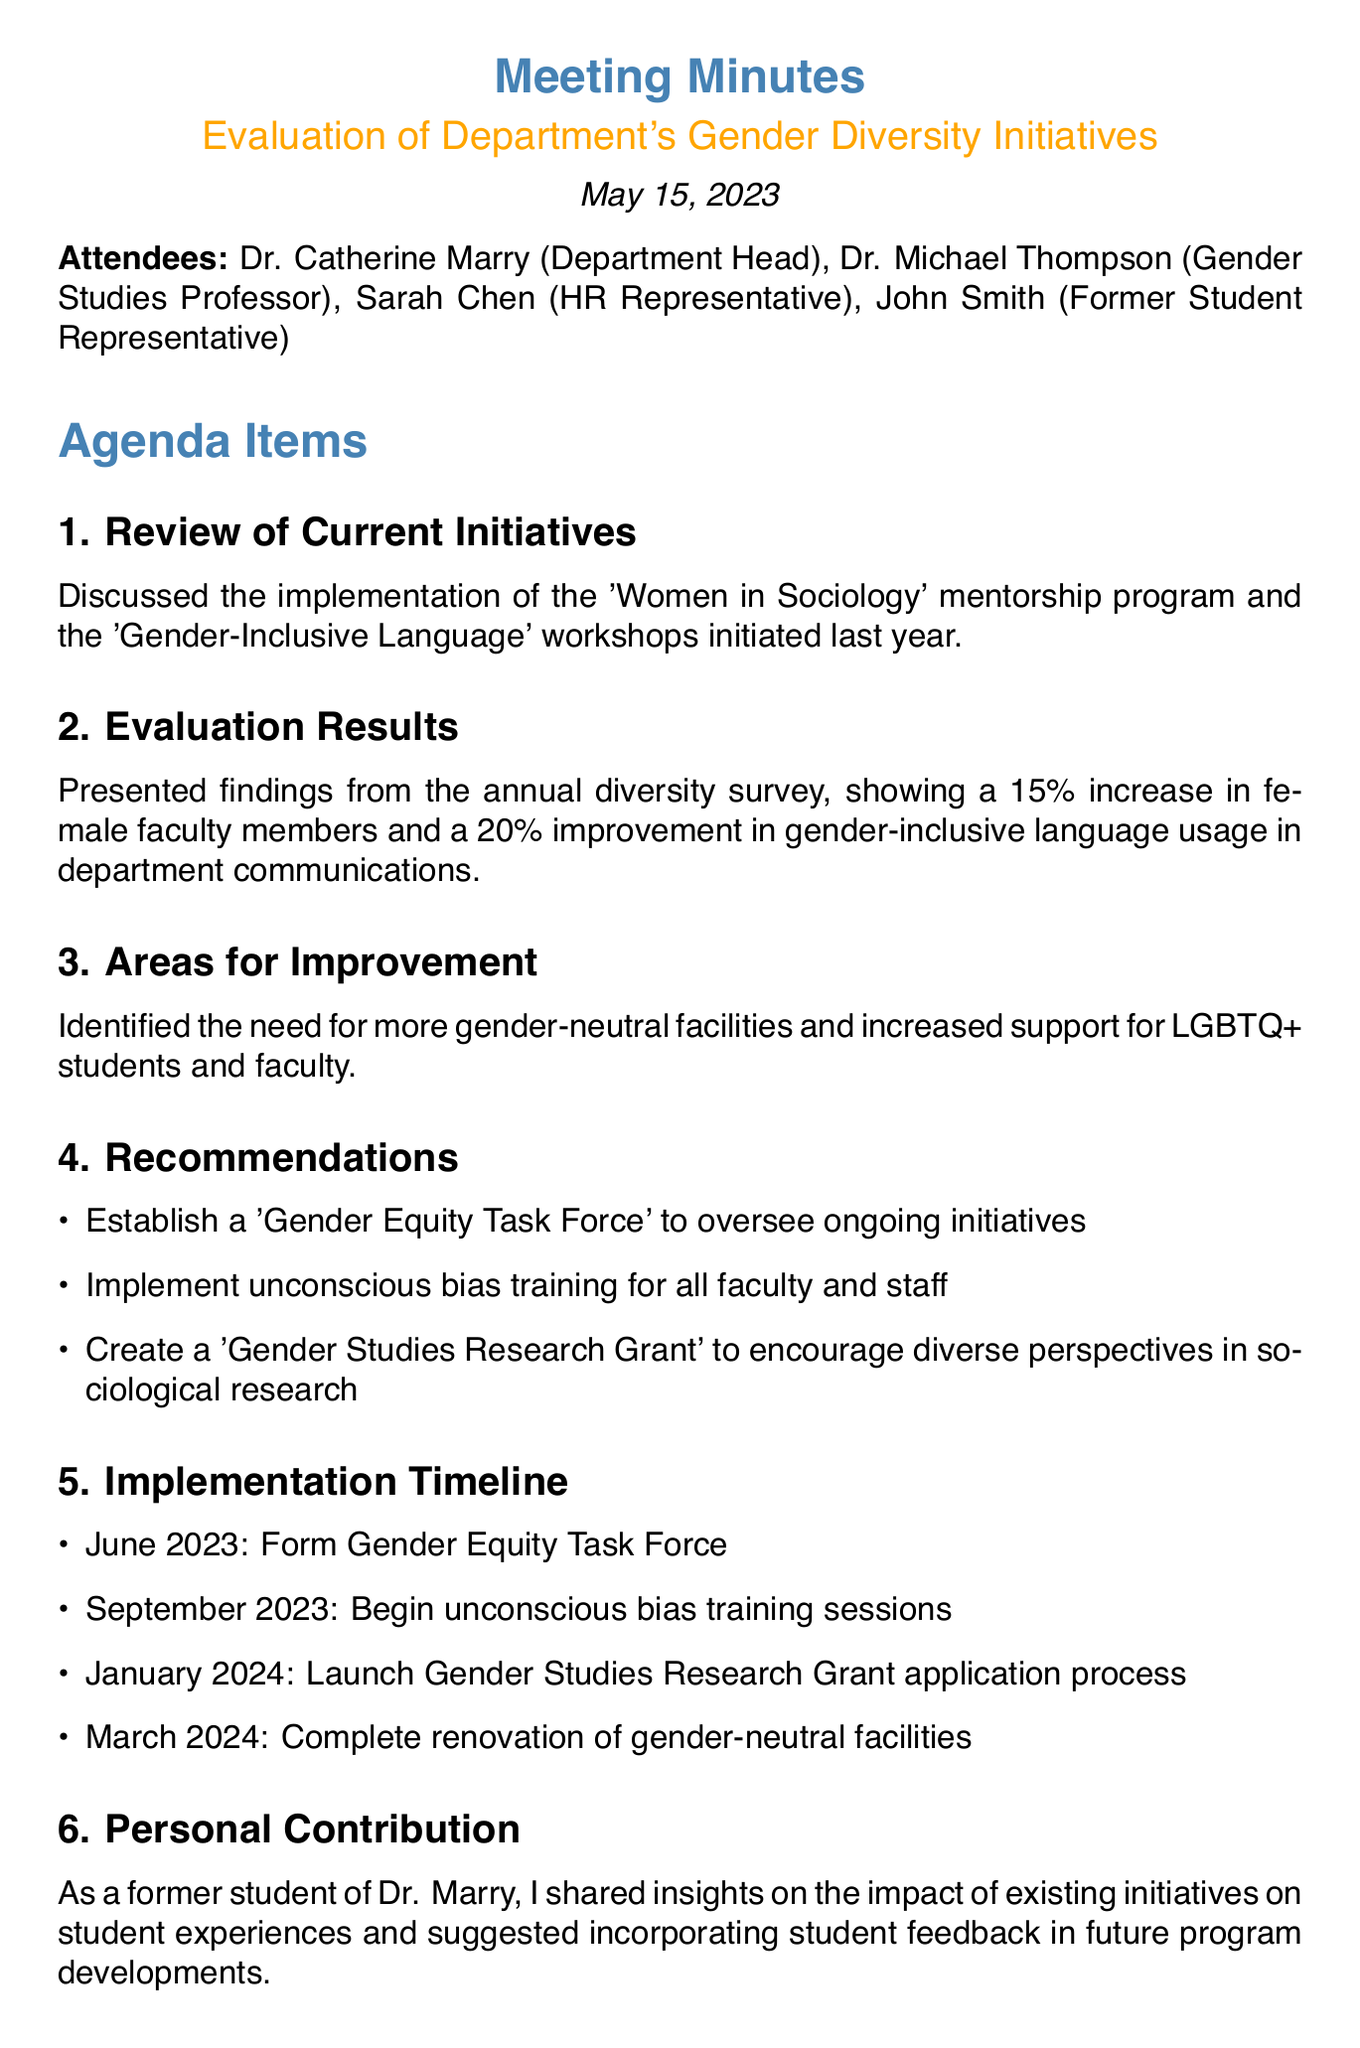What is the meeting title? The title of the meeting is stated at the beginning of the document.
Answer: Evaluation of Department's Gender Diversity Initiatives Who is the HR Representative? The HR Representative is mentioned in the list of attendees.
Answer: Sarah Chen What percentage increase in female faculty members was noted? The increase percentage is detailed in the evaluation results section.
Answer: 15% What is one area identified for improvement? Areas for improvement are listed in the relevant section.
Answer: More gender-neutral facilities When is the next meeting scheduled? The next meeting date is explicitly provided at the end of the document.
Answer: August 15, 2023 Who will draft the proposal for the Gender Equity Task Force? This action item is specified in the action items section.
Answer: Dr. Thompson What is one recommendation made during the meeting? Recommendations are summarized and listed in the recommendations section.
Answer: Establish a 'Gender Equity Task Force' When will the unconscious bias training sessions begin? The implementation timeline includes specific dates for various actions.
Answer: September 2023 What kind of feedback was suggested to incorporate in future program developments? The input on feedback is mentioned in the personal contribution section.
Answer: Student feedback 